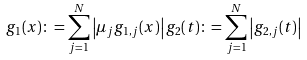<formula> <loc_0><loc_0><loc_500><loc_500>g _ { 1 } ( x ) \colon = \sum _ { j = 1 } ^ { N } \left | \mu _ { j } g _ { 1 , j } ( x ) \right | g _ { 2 } ( t ) \colon = \sum _ { j = 1 } ^ { N } \left | g _ { 2 , j } ( t ) \right |</formula> 